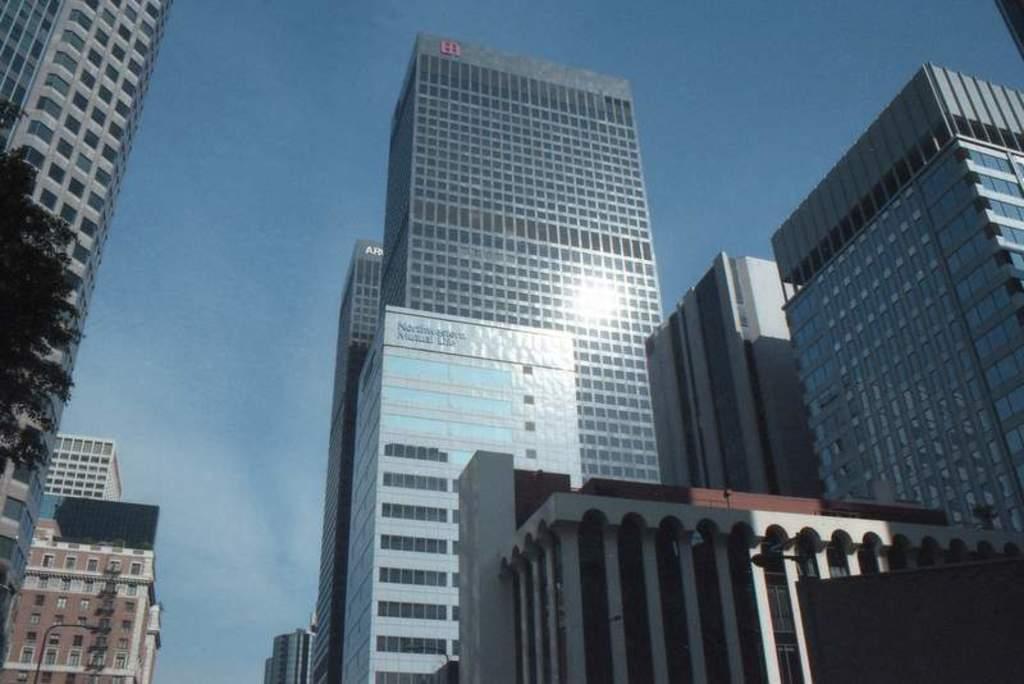Please provide a concise description of this image. In this image we can see some buildings with windows. We can also see a tree, some street poles and the sky. 